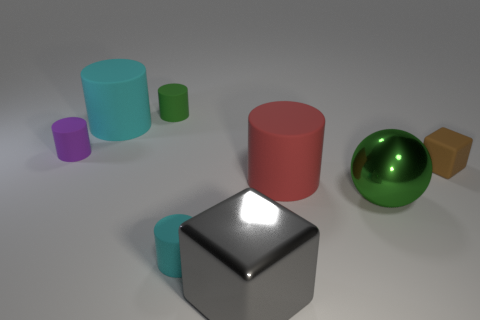What is the material of the brown thing that is the same shape as the big gray object?
Provide a succinct answer. Rubber. Are there any cylinders made of the same material as the large green thing?
Your response must be concise. No. Is there anything else that has the same material as the gray block?
Provide a succinct answer. Yes. The purple cylinder in front of the big rubber thing on the left side of the gray cube is made of what material?
Make the answer very short. Rubber. There is a purple matte cylinder behind the small cylinder that is in front of the cube that is to the right of the gray metallic thing; how big is it?
Offer a terse response. Small. What number of other objects are there of the same shape as the tiny cyan rubber thing?
Provide a succinct answer. 4. Is the color of the large rubber cylinder left of the green matte object the same as the cylinder to the right of the gray metal cube?
Offer a very short reply. No. There is a shiny sphere that is the same size as the shiny cube; what color is it?
Provide a short and direct response. Green. Are there any tiny cylinders of the same color as the small rubber cube?
Provide a short and direct response. No. There is a cyan thing behind the brown rubber block; does it have the same size as the big gray metallic cube?
Keep it short and to the point. Yes. 